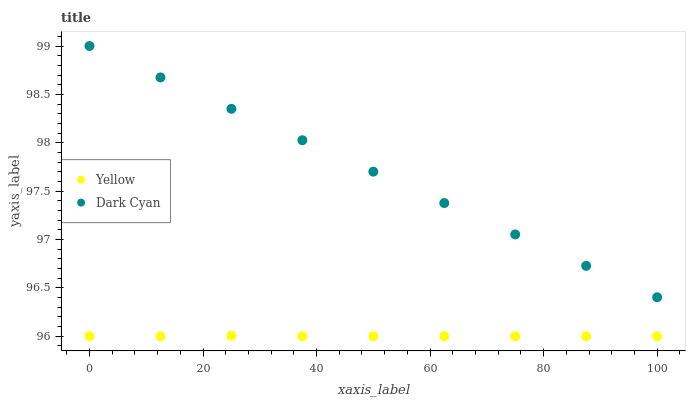Does Yellow have the minimum area under the curve?
Answer yes or no. Yes. Does Dark Cyan have the maximum area under the curve?
Answer yes or no. Yes. Does Yellow have the maximum area under the curve?
Answer yes or no. No. Is Dark Cyan the smoothest?
Answer yes or no. Yes. Is Yellow the roughest?
Answer yes or no. Yes. Is Yellow the smoothest?
Answer yes or no. No. Does Yellow have the lowest value?
Answer yes or no. Yes. Does Dark Cyan have the highest value?
Answer yes or no. Yes. Does Yellow have the highest value?
Answer yes or no. No. Is Yellow less than Dark Cyan?
Answer yes or no. Yes. Is Dark Cyan greater than Yellow?
Answer yes or no. Yes. Does Yellow intersect Dark Cyan?
Answer yes or no. No. 